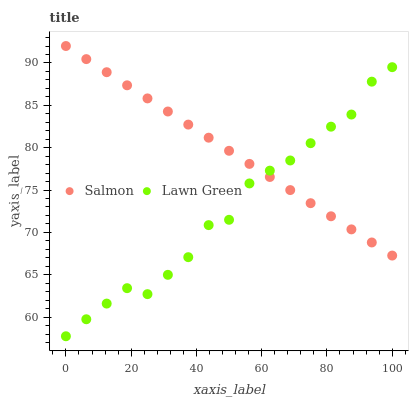Does Lawn Green have the minimum area under the curve?
Answer yes or no. Yes. Does Salmon have the maximum area under the curve?
Answer yes or no. Yes. Does Salmon have the minimum area under the curve?
Answer yes or no. No. Is Salmon the smoothest?
Answer yes or no. Yes. Is Lawn Green the roughest?
Answer yes or no. Yes. Is Salmon the roughest?
Answer yes or no. No. Does Lawn Green have the lowest value?
Answer yes or no. Yes. Does Salmon have the lowest value?
Answer yes or no. No. Does Salmon have the highest value?
Answer yes or no. Yes. Does Salmon intersect Lawn Green?
Answer yes or no. Yes. Is Salmon less than Lawn Green?
Answer yes or no. No. Is Salmon greater than Lawn Green?
Answer yes or no. No. 